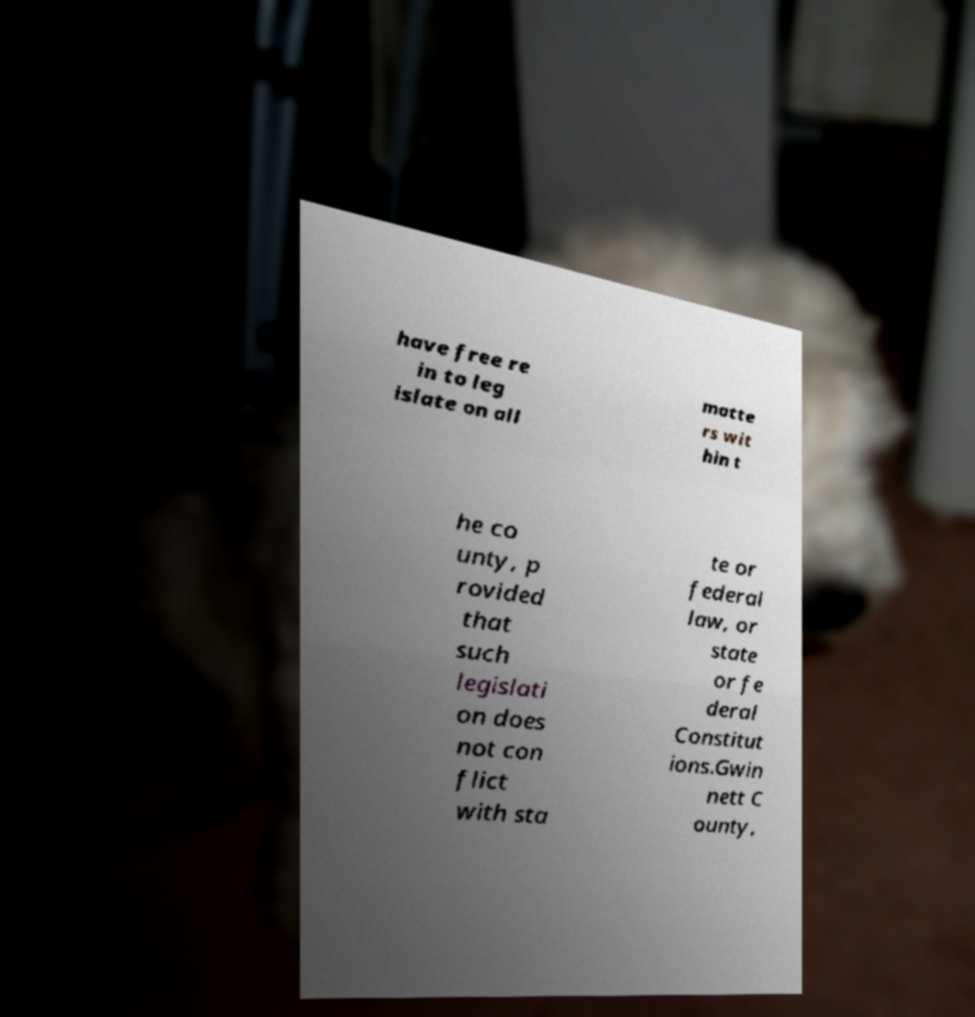Can you accurately transcribe the text from the provided image for me? have free re in to leg islate on all matte rs wit hin t he co unty, p rovided that such legislati on does not con flict with sta te or federal law, or state or fe deral Constitut ions.Gwin nett C ounty, 